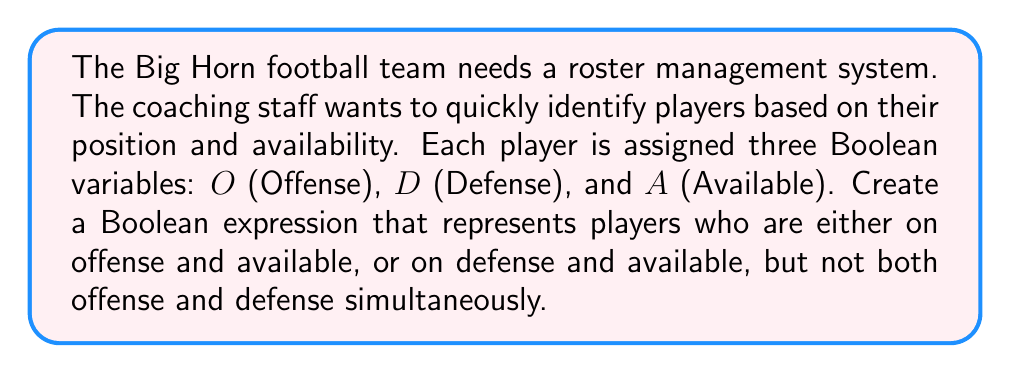What is the answer to this math problem? Let's approach this step-by-step:

1) We want players who are:
   - On offense and available, OR
   - On defense and available
   
   This can be represented as: $(O \land A) \lor (D \land A)$

2) However, we don't want players who are both on offense and defense.
   This exclusion can be represented as: $\lnot(O \land D)$

3) Combining these conditions using AND (∧), we get:
   $((O \land A) \lor (D \land A)) \land \lnot(O \land D)$

4) We can simplify this expression:
   
   $((O \land A) \lor (D \land A)) \land \lnot(O \land D)$
   
   $= ((O \lor D) \land A) \land \lnot(O \land D)$  (Distributive property)
   
   $= (O \lor D) \land A \land (\lnot O \lor \lnot D)$  (De Morgan's Law)
   
   $= ((O \land \lnot D) \lor (D \land \lnot O)) \land A$  (Distributive property)

5) This final expression represents players who are either on offense or defense (but not both) and are available.
Answer: $((O \land \lnot D) \lor (D \land \lnot O)) \land A$ 